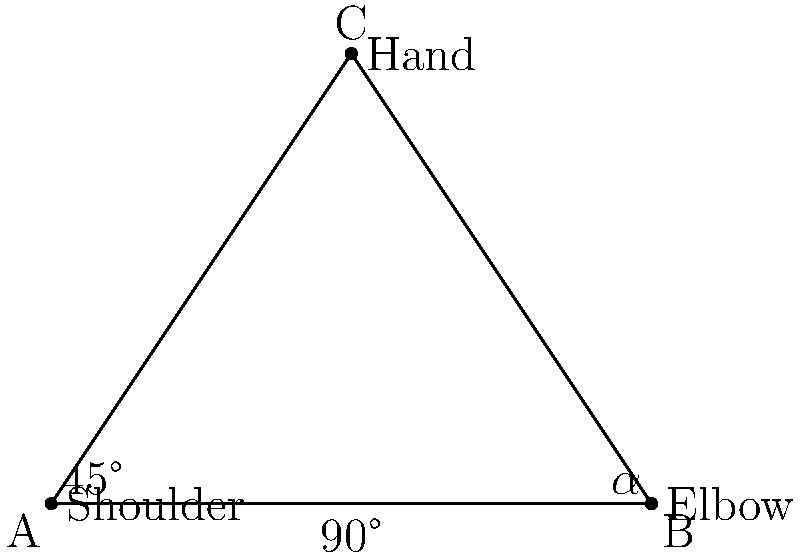During a volleyball serve, a player's arm forms a right triangle with the shoulder as point A, elbow as point B, and hand as point C. If the angle at the shoulder (∠CAB) is 45°, what is the measure of angle α (∠ABC)? Let's approach this step-by-step:

1) In a triangle, the sum of all interior angles is always 180°.

2) We're given that this is a right triangle, so one of the angles (∠ACB) is 90°.

3) We're also told that the angle at the shoulder (∠CAB) is 45°.

4) Let's call the angle we're looking for (∠ABC) α.

5) Now we can set up an equation based on the fact that the angles in a triangle sum to 180°:

   $$90° + 45° + \alpha = 180°$$

6) Simplifying:
   $$135° + \alpha = 180°$$

7) Subtracting 135° from both sides:
   $$\alpha = 180° - 135° = 45°$$

Therefore, the measure of angle α (∠ABC) is 45°.
Answer: 45° 